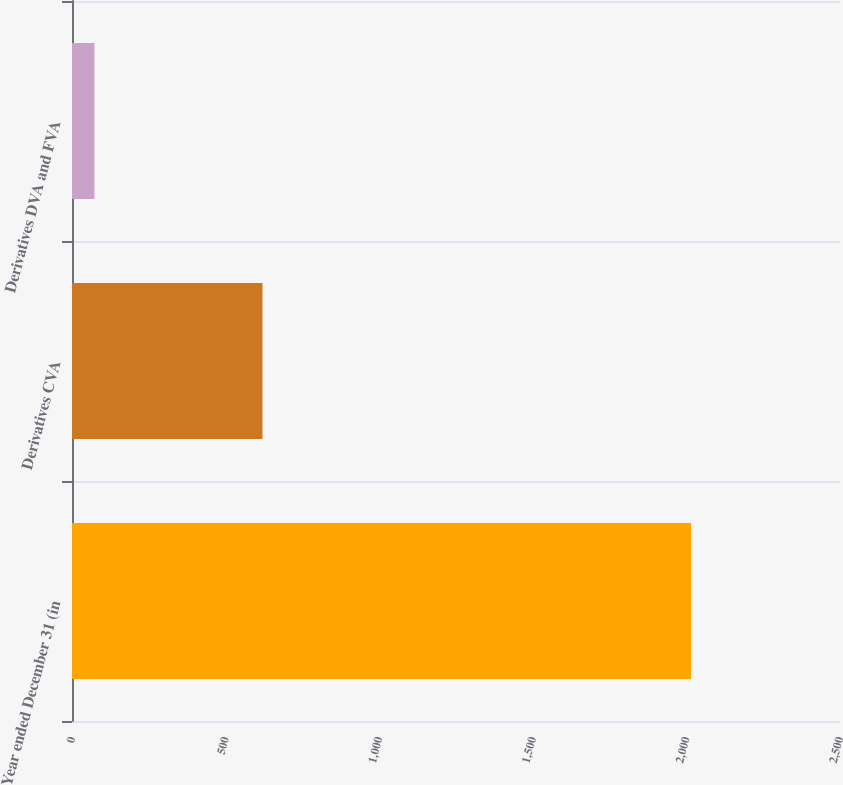Convert chart. <chart><loc_0><loc_0><loc_500><loc_500><bar_chart><fcel>Year ended December 31 (in<fcel>Derivatives CVA<fcel>Derivatives DVA and FVA<nl><fcel>2015<fcel>620<fcel>73<nl></chart> 